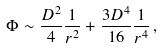<formula> <loc_0><loc_0><loc_500><loc_500>\Phi \sim \frac { D ^ { 2 } } { 4 } \frac { 1 } { r ^ { 2 } } + \frac { 3 D ^ { 4 } } { 1 6 } \frac { 1 } { r ^ { 4 } } \, ,</formula> 